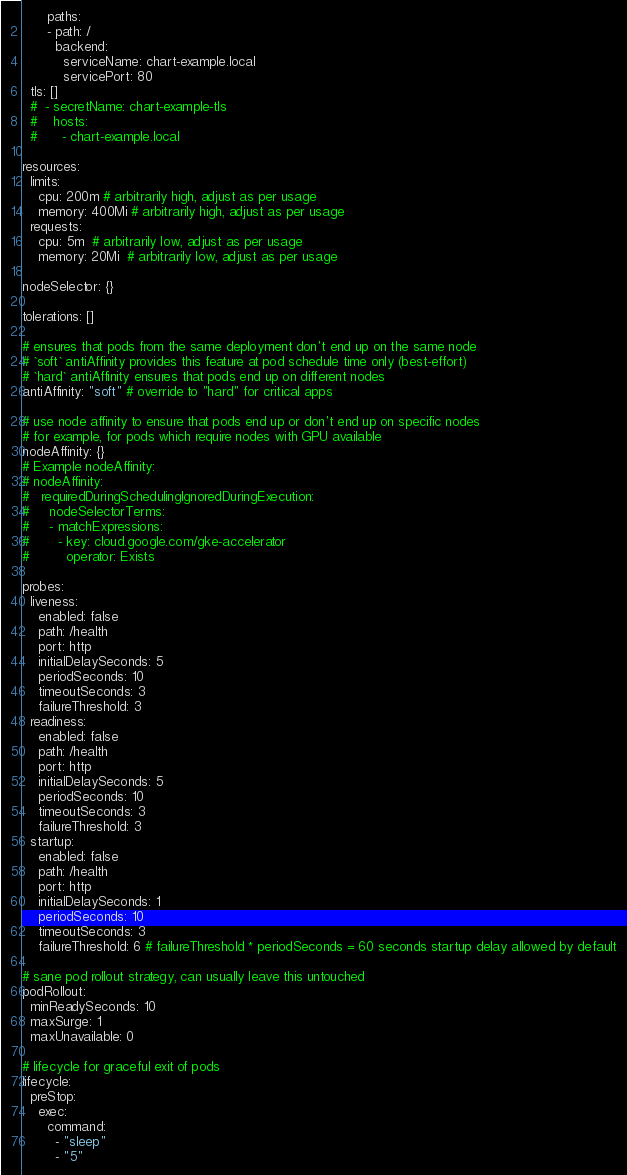<code> <loc_0><loc_0><loc_500><loc_500><_YAML_>      paths:
      - path: /
        backend:
          serviceName: chart-example.local
          servicePort: 80
  tls: []
  #  - secretName: chart-example-tls
  #    hosts:
  #      - chart-example.local

resources:
  limits:
    cpu: 200m # arbitrarily high, adjust as per usage
    memory: 400Mi # arbitrarily high, adjust as per usage
  requests:
    cpu: 5m  # arbitrarily low, adjust as per usage
    memory: 20Mi  # arbitrarily low, adjust as per usage

nodeSelector: {}

tolerations: []

# ensures that pods from the same deployment don't end up on the same node
# `soft` antiAffinity provides this feature at pod schedule time only (best-effort)
# `hard` antiAffinity ensures that pods end up on different nodes
antiAffinity: "soft" # override to "hard" for critical apps

# use node affinity to ensure that pods end up or don't end up on specific nodes
# for example, for pods which require nodes with GPU available
nodeAffinity: {}
# Example nodeAffinity:
# nodeAffinity:
#   requiredDuringSchedulingIgnoredDuringExecution:
#     nodeSelectorTerms:
#     - matchExpressions:
#       - key: cloud.google.com/gke-accelerator
#         operator: Exists

probes:
  liveness:
    enabled: false
    path: /health
    port: http
    initialDelaySeconds: 5
    periodSeconds: 10
    timeoutSeconds: 3
    failureThreshold: 3
  readiness:
    enabled: false
    path: /health
    port: http
    initialDelaySeconds: 5
    periodSeconds: 10
    timeoutSeconds: 3
    failureThreshold: 3
  startup:
    enabled: false
    path: /health
    port: http
    initialDelaySeconds: 1
    periodSeconds: 10
    timeoutSeconds: 3
    failureThreshold: 6 # failureThreshold * periodSeconds = 60 seconds startup delay allowed by default

# sane pod rollout strategy, can usually leave this untouched
podRollout:
  minReadySeconds: 10
  maxSurge: 1
  maxUnavailable: 0

# lifecycle for graceful exit of pods
lifecycle:
  preStop:
    exec:
      command:
        - "sleep"
        - "5"
</code> 